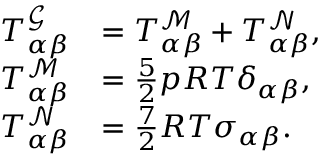Convert formula to latex. <formula><loc_0><loc_0><loc_500><loc_500>\begin{array} { r l } { T _ { \alpha \beta } ^ { \mathcal { G } } } & { = T _ { \alpha \beta } ^ { \mathcal { M } } + T _ { \alpha \beta } ^ { \mathcal { N } } , } \\ { T _ { \alpha \beta } ^ { \mathcal { M } } } & { = \frac { 5 } { 2 } p R T \delta _ { \alpha \beta } , } \\ { T _ { \alpha \beta } ^ { \mathcal { N } } } & { = \frac { 7 } { 2 } R T \sigma _ { \alpha \beta } . } \end{array}</formula> 